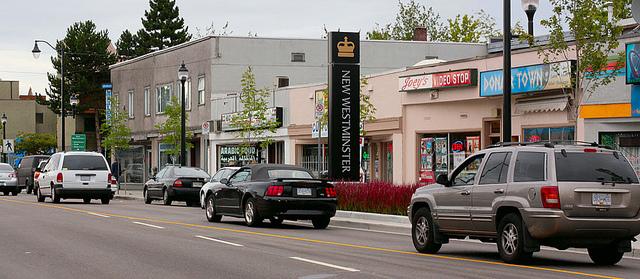Is the black car in the middle of the frame a convertible?
Answer briefly. Yes. Which vehicle is a Jeep brand?
Be succinct. Middle. Are the cars moving?
Keep it brief. Yes. Is there a video store in the picture?
Short answer required. Yes. Is this an American town?
Write a very short answer. Yes. What is the man riding?
Quick response, please. Car. Is there a silver PT Cruiser?
Quick response, please. No. 